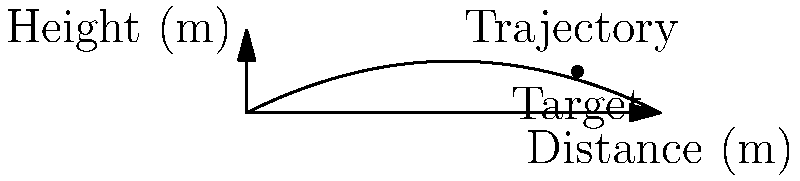In a new first-person shooter game, you're testing a grenade launcher. The trajectory of the grenade follows a parabolic path described by the equation $h(x) = -0.05x^2 + 0.5x$, where $h$ is the height in meters and $x$ is the horizontal distance in meters. The target is located 8 meters away at a height of 1 meter. What is the optimal launch angle (in degrees) to hit the target directly? To find the optimal launch angle, we need to follow these steps:

1) First, we need to find the height of the projectile at the target's horizontal position. We can do this by plugging $x = 8$ into the trajectory equation:

   $h(8) = -0.05(8^2) + 0.5(8) = -0.05(64) + 4 = -3.2 + 4 = 0.8$ meters

2) Now we know that the projectile needs to gain 0.2 meters in height to reach the target (1 m - 0.8 m = 0.2 m).

3) To find the angle, we can use the tangent function. The tangent of the angle is the ratio of the vertical distance to the horizontal distance:

   $\tan(\theta) = \frac{\text{vertical distance}}{\text{horizontal distance}} = \frac{0.2}{8} = 0.025$

4) To get the angle, we need to take the inverse tangent (arctangent):

   $\theta = \arctan(0.025)$

5) Convert this to degrees:

   $\theta = \arctan(0.025) * \frac{180}{\pi} \approx 1.43°$

Therefore, the optimal launch angle is approximately 1.43 degrees.
Answer: 1.43° 